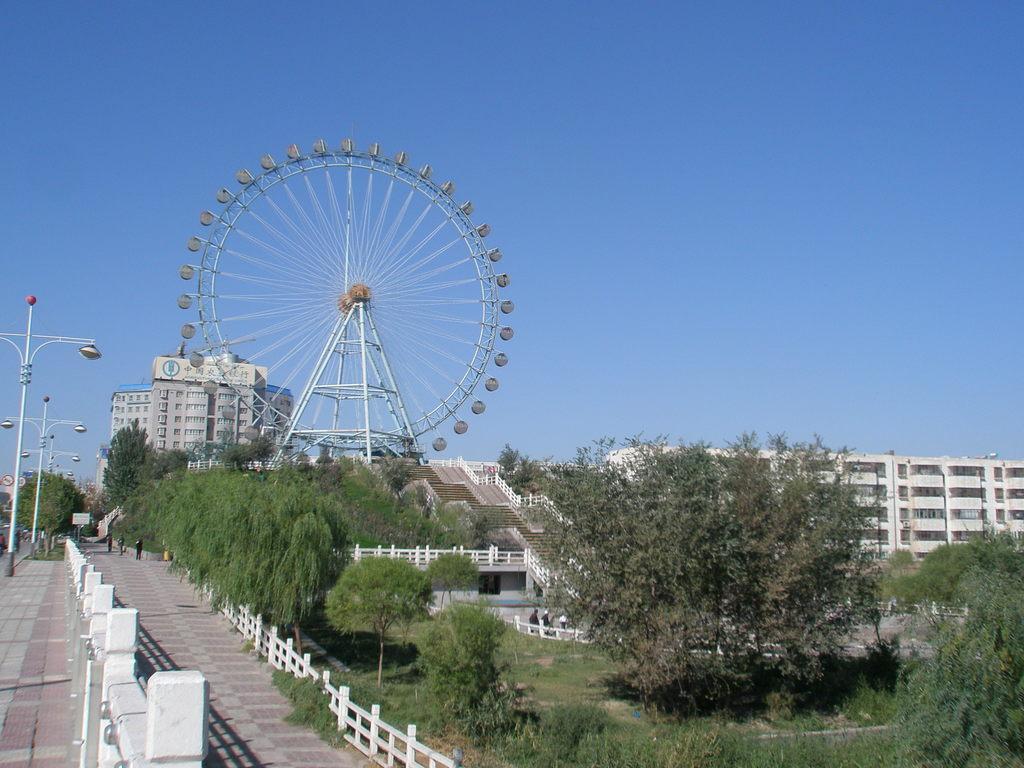Describe this image in one or two sentences. In this picture there are poles on the left side of the image and there are trees on the right side of the image, there are buildings and a giant wheel in the background area of the image and there is a boundary at the bottom side of the. 